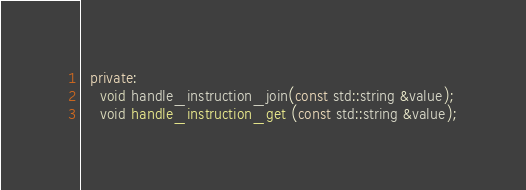<code> <loc_0><loc_0><loc_500><loc_500><_C++_>  private:
    void handle_instruction_join(const std::string &value);
    void handle_instruction_get (const std::string &value);</code> 